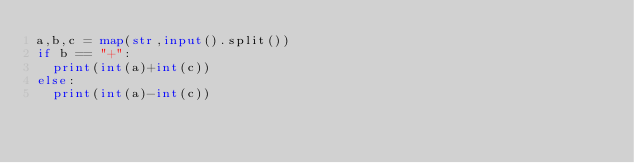Convert code to text. <code><loc_0><loc_0><loc_500><loc_500><_Python_>a,b,c = map(str,input().split())
if b == "+":
  print(int(a)+int(c))
else:
  print(int(a)-int(c))</code> 